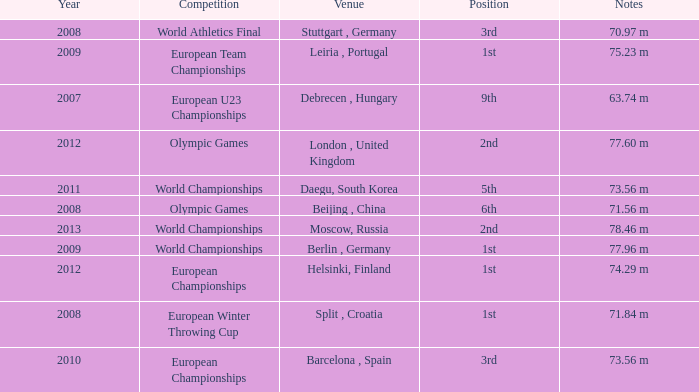Which Year has a Position of 9th? 2007.0. Could you help me parse every detail presented in this table? {'header': ['Year', 'Competition', 'Venue', 'Position', 'Notes'], 'rows': [['2008', 'World Athletics Final', 'Stuttgart , Germany', '3rd', '70.97 m'], ['2009', 'European Team Championships', 'Leiria , Portugal', '1st', '75.23 m'], ['2007', 'European U23 Championships', 'Debrecen , Hungary', '9th', '63.74 m'], ['2012', 'Olympic Games', 'London , United Kingdom', '2nd', '77.60 m'], ['2011', 'World Championships', 'Daegu, South Korea', '5th', '73.56 m'], ['2008', 'Olympic Games', 'Beijing , China', '6th', '71.56 m'], ['2013', 'World Championships', 'Moscow, Russia', '2nd', '78.46 m'], ['2009', 'World Championships', 'Berlin , Germany', '1st', '77.96 m'], ['2012', 'European Championships', 'Helsinki, Finland', '1st', '74.29 m'], ['2008', 'European Winter Throwing Cup', 'Split , Croatia', '1st', '71.84 m'], ['2010', 'European Championships', 'Barcelona , Spain', '3rd', '73.56 m']]} 